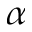Convert formula to latex. <formula><loc_0><loc_0><loc_500><loc_500>\alpha</formula> 